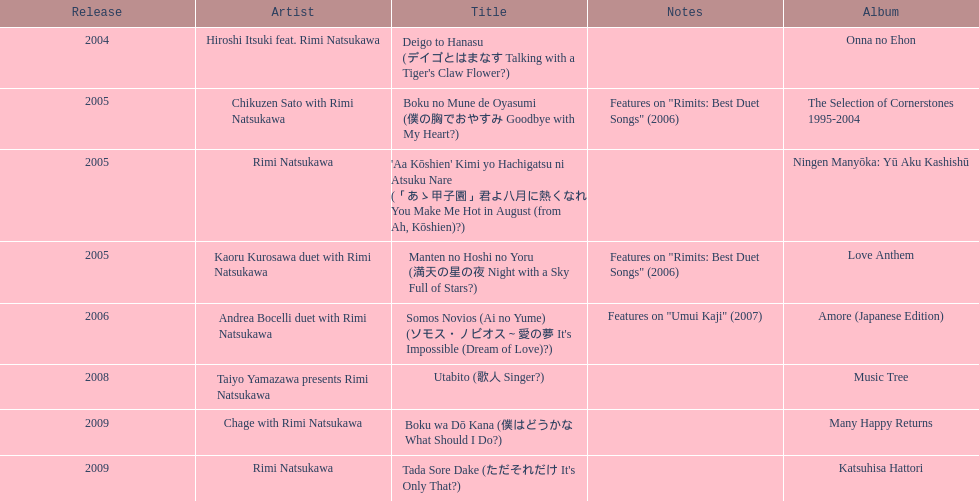What was the album released immediately before the one that had boku wa do kana on it? Music Tree. 